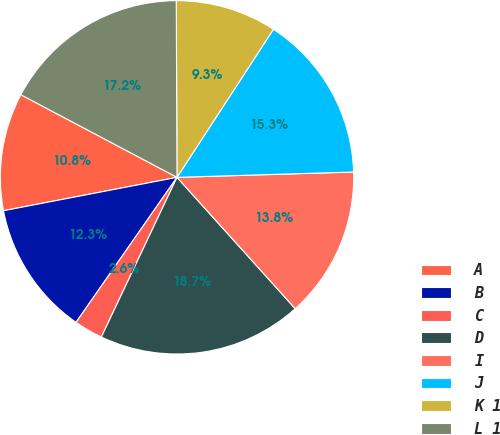<chart> <loc_0><loc_0><loc_500><loc_500><pie_chart><fcel>A<fcel>B<fcel>C<fcel>D<fcel>I<fcel>J<fcel>K 1<fcel>L 1<nl><fcel>10.77%<fcel>12.29%<fcel>2.64%<fcel>18.7%<fcel>13.81%<fcel>15.33%<fcel>9.25%<fcel>17.18%<nl></chart> 